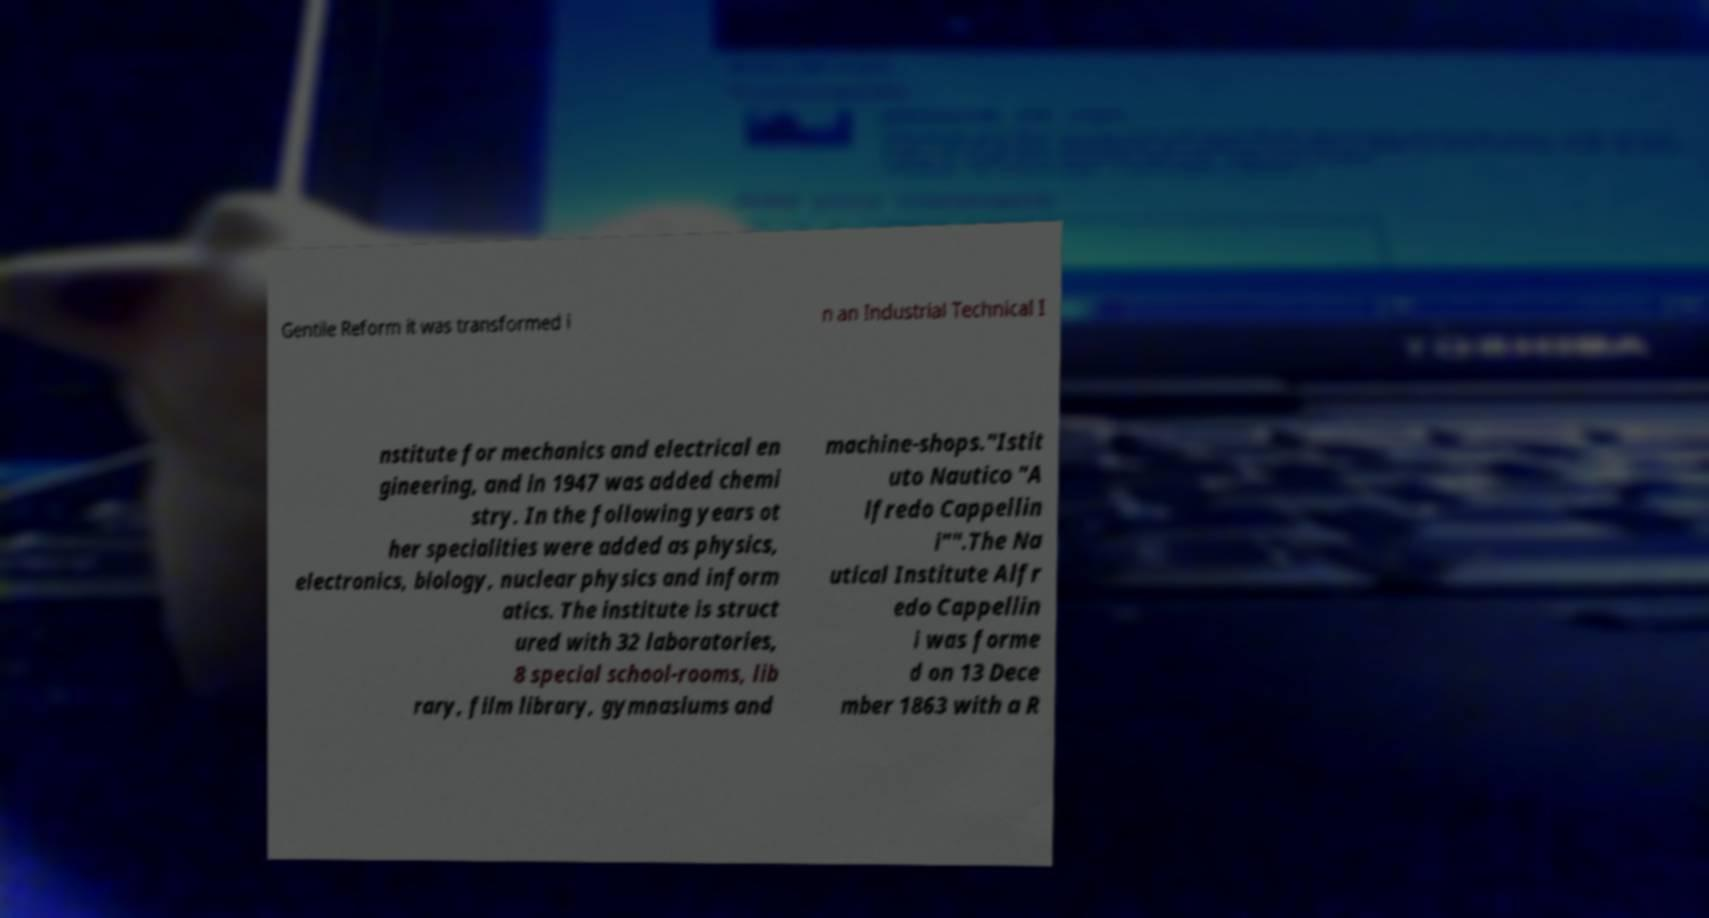Could you assist in decoding the text presented in this image and type it out clearly? Gentile Reform it was transformed i n an Industrial Technical I nstitute for mechanics and electrical en gineering, and in 1947 was added chemi stry. In the following years ot her specialities were added as physics, electronics, biology, nuclear physics and inform atics. The institute is struct ured with 32 laboratories, 8 special school-rooms, lib rary, film library, gymnasiums and machine-shops."Istit uto Nautico "A lfredo Cappellin i"".The Na utical Institute Alfr edo Cappellin i was forme d on 13 Dece mber 1863 with a R 